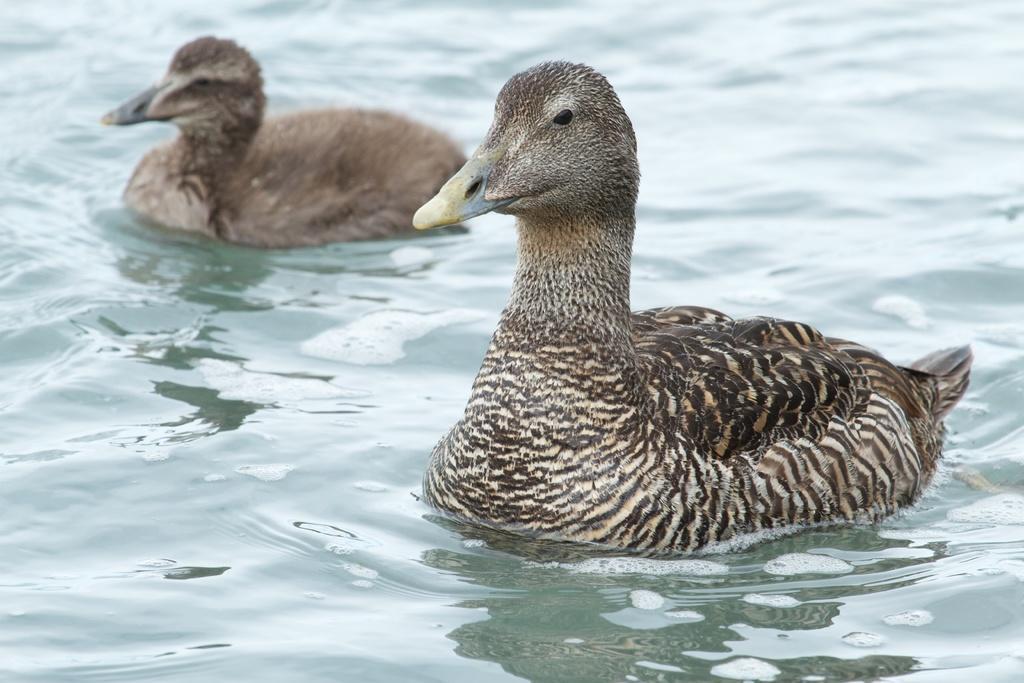How would you summarize this image in a sentence or two? In this image I can see two birds which are brown, cream, yellow and black in color on the surface of the water. 